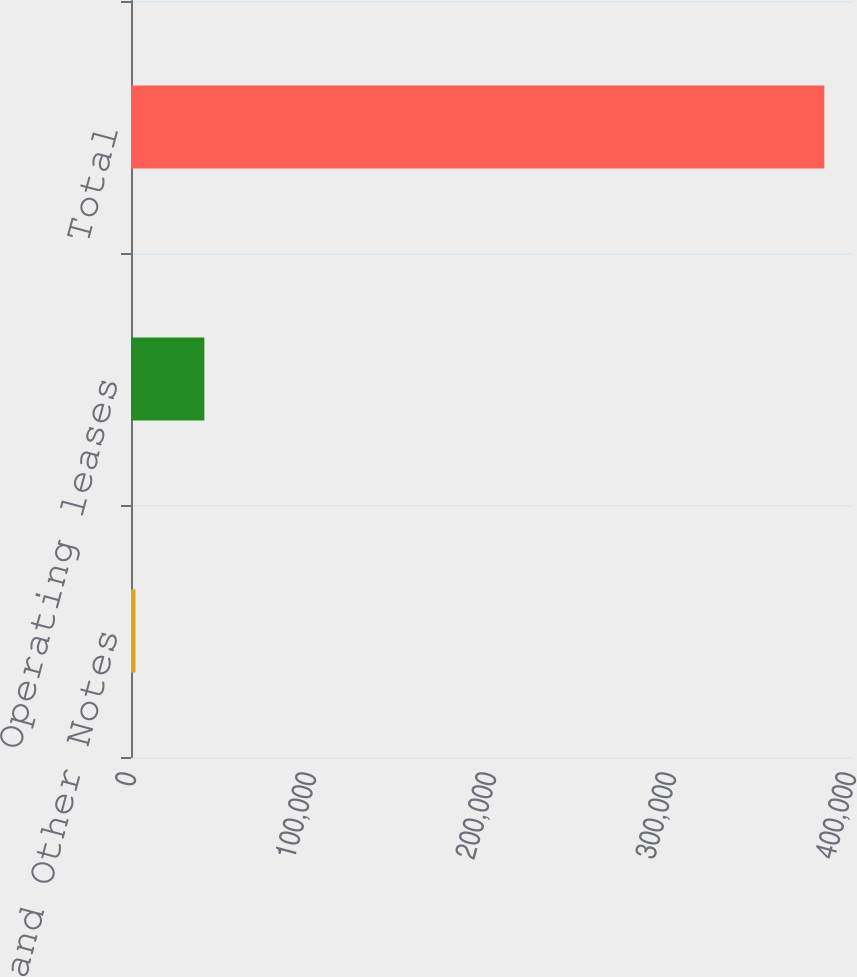<chart> <loc_0><loc_0><loc_500><loc_500><bar_chart><fcel>Mortgages and Other Notes<fcel>Operating leases<fcel>Total<nl><fcel>2491<fcel>40760.8<fcel>385189<nl></chart> 